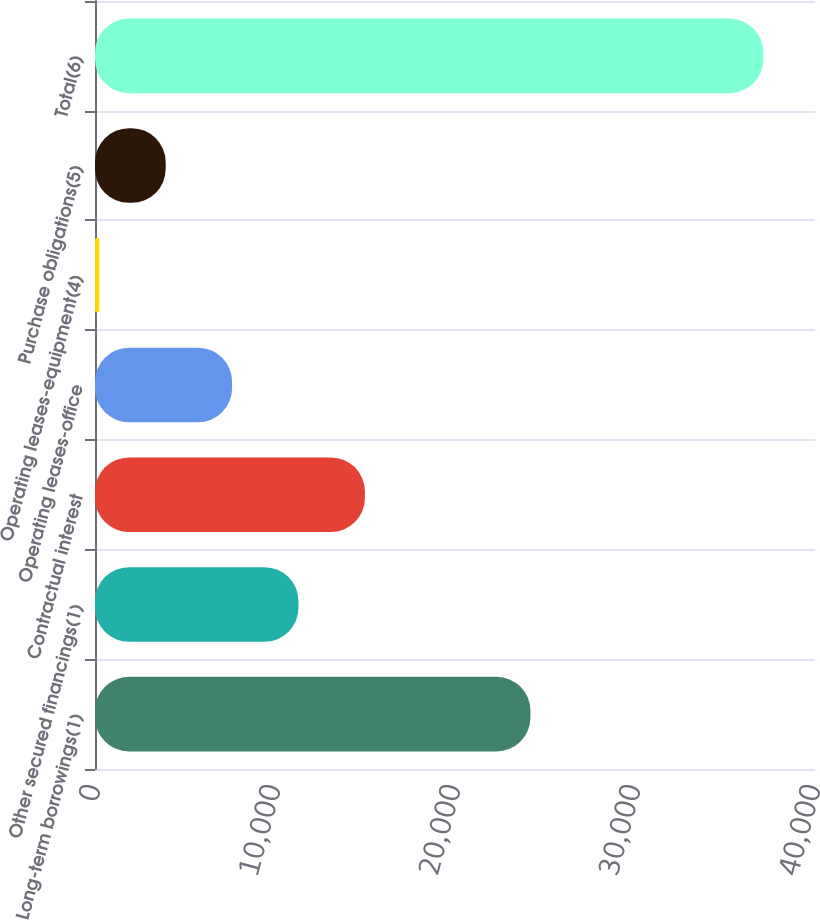<chart> <loc_0><loc_0><loc_500><loc_500><bar_chart><fcel>Long-term borrowings(1)<fcel>Other secured financings(1)<fcel>Contractual interest<fcel>Operating leases-office<fcel>Operating leases-equipment(4)<fcel>Purchase obligations(5)<fcel>Total(6)<nl><fcel>24193<fcel>11305.7<fcel>14994.6<fcel>7616.8<fcel>239<fcel>3927.9<fcel>37128<nl></chart> 